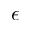<formula> <loc_0><loc_0><loc_500><loc_500>\epsilon</formula> 